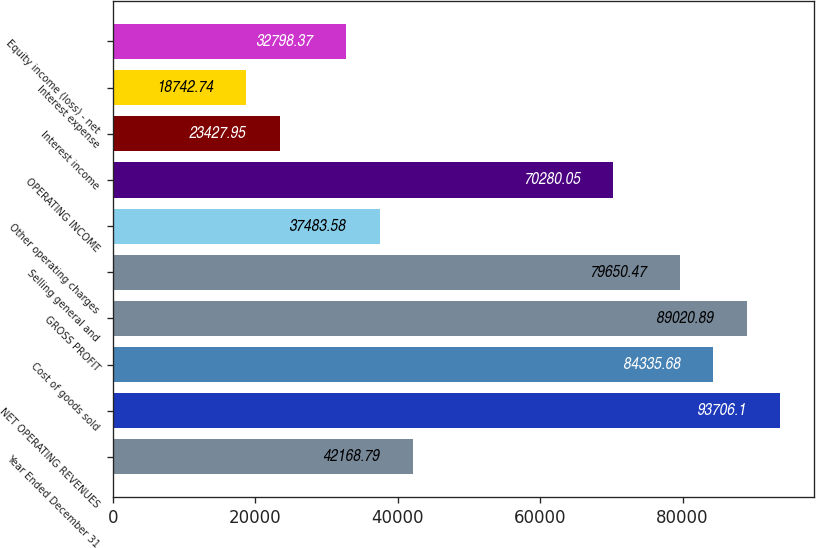Convert chart to OTSL. <chart><loc_0><loc_0><loc_500><loc_500><bar_chart><fcel>Year Ended December 31<fcel>NET OPERATING REVENUES<fcel>Cost of goods sold<fcel>GROSS PROFIT<fcel>Selling general and<fcel>Other operating charges<fcel>OPERATING INCOME<fcel>Interest income<fcel>Interest expense<fcel>Equity income (loss) - net<nl><fcel>42168.8<fcel>93706.1<fcel>84335.7<fcel>89020.9<fcel>79650.5<fcel>37483.6<fcel>70280.1<fcel>23428<fcel>18742.7<fcel>32798.4<nl></chart> 